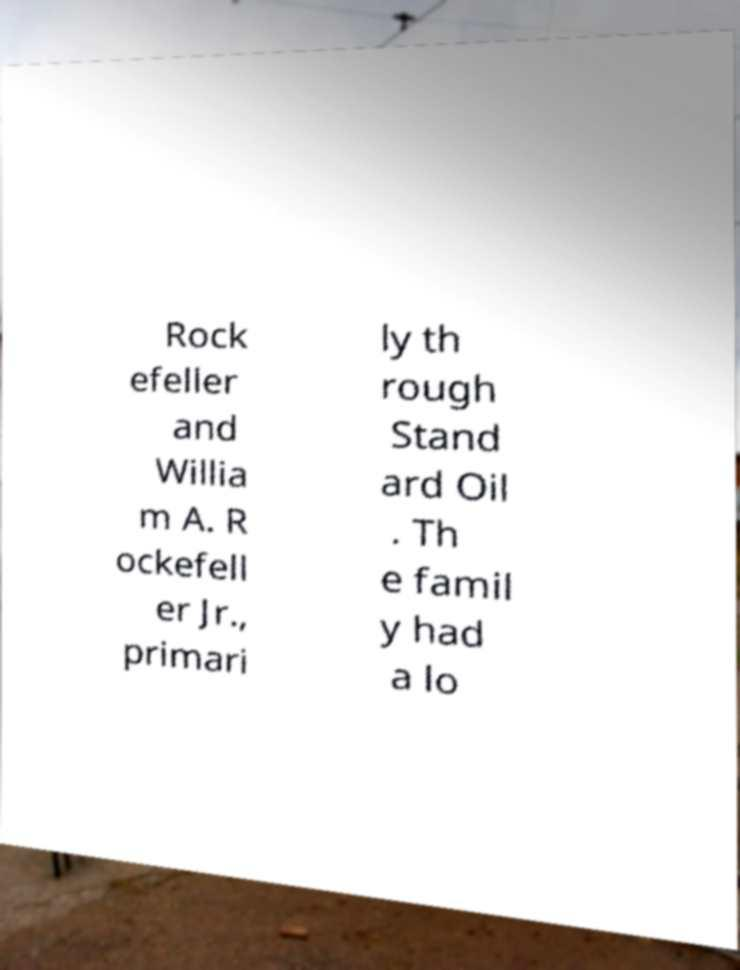Can you read and provide the text displayed in the image?This photo seems to have some interesting text. Can you extract and type it out for me? Rock efeller and Willia m A. R ockefell er Jr., primari ly th rough Stand ard Oil . Th e famil y had a lo 